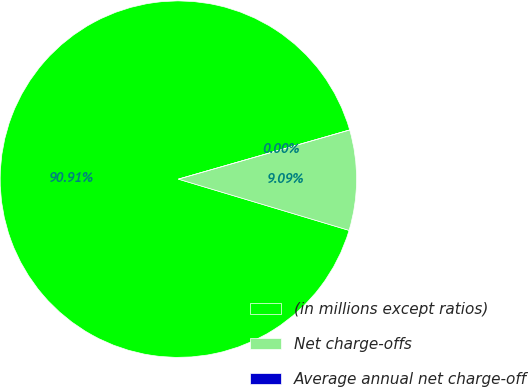<chart> <loc_0><loc_0><loc_500><loc_500><pie_chart><fcel>(in millions except ratios)<fcel>Net charge-offs<fcel>Average annual net charge-off<nl><fcel>90.91%<fcel>9.09%<fcel>0.0%<nl></chart> 